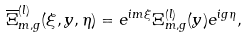Convert formula to latex. <formula><loc_0><loc_0><loc_500><loc_500>\overline { \Xi } ^ { ( l ) } _ { m , g } ( \xi , y , \eta ) = e ^ { i m \xi } \Xi ^ { ( l ) } _ { m , g } ( y ) e ^ { i g \eta } ,</formula> 